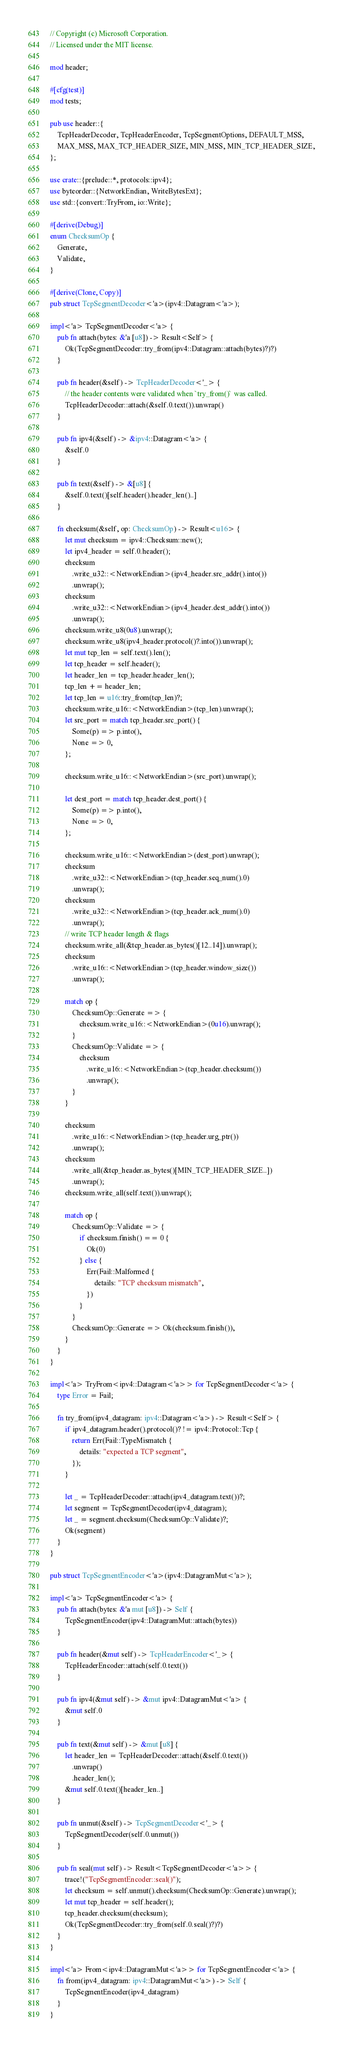<code> <loc_0><loc_0><loc_500><loc_500><_Rust_>// Copyright (c) Microsoft Corporation.
// Licensed under the MIT license.

mod header;

#[cfg(test)]
mod tests;

pub use header::{
    TcpHeaderDecoder, TcpHeaderEncoder, TcpSegmentOptions, DEFAULT_MSS,
    MAX_MSS, MAX_TCP_HEADER_SIZE, MIN_MSS, MIN_TCP_HEADER_SIZE,
};

use crate::{prelude::*, protocols::ipv4};
use byteorder::{NetworkEndian, WriteBytesExt};
use std::{convert::TryFrom, io::Write};

#[derive(Debug)]
enum ChecksumOp {
    Generate,
    Validate,
}

#[derive(Clone, Copy)]
pub struct TcpSegmentDecoder<'a>(ipv4::Datagram<'a>);

impl<'a> TcpSegmentDecoder<'a> {
    pub fn attach(bytes: &'a [u8]) -> Result<Self> {
        Ok(TcpSegmentDecoder::try_from(ipv4::Datagram::attach(bytes)?)?)
    }

    pub fn header(&self) -> TcpHeaderDecoder<'_> {
        // the header contents were validated when `try_from()` was called.
        TcpHeaderDecoder::attach(&self.0.text()).unwrap()
    }

    pub fn ipv4(&self) -> &ipv4::Datagram<'a> {
        &self.0
    }

    pub fn text(&self) -> &[u8] {
        &self.0.text()[self.header().header_len()..]
    }

    fn checksum(&self, op: ChecksumOp) -> Result<u16> {
        let mut checksum = ipv4::Checksum::new();
        let ipv4_header = self.0.header();
        checksum
            .write_u32::<NetworkEndian>(ipv4_header.src_addr().into())
            .unwrap();
        checksum
            .write_u32::<NetworkEndian>(ipv4_header.dest_addr().into())
            .unwrap();
        checksum.write_u8(0u8).unwrap();
        checksum.write_u8(ipv4_header.protocol()?.into()).unwrap();
        let mut tcp_len = self.text().len();
        let tcp_header = self.header();
        let header_len = tcp_header.header_len();
        tcp_len += header_len;
        let tcp_len = u16::try_from(tcp_len)?;
        checksum.write_u16::<NetworkEndian>(tcp_len).unwrap();
        let src_port = match tcp_header.src_port() {
            Some(p) => p.into(),
            None => 0,
        };

        checksum.write_u16::<NetworkEndian>(src_port).unwrap();

        let dest_port = match tcp_header.dest_port() {
            Some(p) => p.into(),
            None => 0,
        };

        checksum.write_u16::<NetworkEndian>(dest_port).unwrap();
        checksum
            .write_u32::<NetworkEndian>(tcp_header.seq_num().0)
            .unwrap();
        checksum
            .write_u32::<NetworkEndian>(tcp_header.ack_num().0)
            .unwrap();
        // write TCP header length & flags
        checksum.write_all(&tcp_header.as_bytes()[12..14]).unwrap();
        checksum
            .write_u16::<NetworkEndian>(tcp_header.window_size())
            .unwrap();

        match op {
            ChecksumOp::Generate => {
                checksum.write_u16::<NetworkEndian>(0u16).unwrap();
            }
            ChecksumOp::Validate => {
                checksum
                    .write_u16::<NetworkEndian>(tcp_header.checksum())
                    .unwrap();
            }
        }

        checksum
            .write_u16::<NetworkEndian>(tcp_header.urg_ptr())
            .unwrap();
        checksum
            .write_all(&tcp_header.as_bytes()[MIN_TCP_HEADER_SIZE..])
            .unwrap();
        checksum.write_all(self.text()).unwrap();

        match op {
            ChecksumOp::Validate => {
                if checksum.finish() == 0 {
                    Ok(0)
                } else {
                    Err(Fail::Malformed {
                        details: "TCP checksum mismatch",
                    })
                }
            }
            ChecksumOp::Generate => Ok(checksum.finish()),
        }
    }
}

impl<'a> TryFrom<ipv4::Datagram<'a>> for TcpSegmentDecoder<'a> {
    type Error = Fail;

    fn try_from(ipv4_datagram: ipv4::Datagram<'a>) -> Result<Self> {
        if ipv4_datagram.header().protocol()? != ipv4::Protocol::Tcp {
            return Err(Fail::TypeMismatch {
                details: "expected a TCP segment",
            });
        }

        let _ = TcpHeaderDecoder::attach(ipv4_datagram.text())?;
        let segment = TcpSegmentDecoder(ipv4_datagram);
        let _ = segment.checksum(ChecksumOp::Validate)?;
        Ok(segment)
    }
}

pub struct TcpSegmentEncoder<'a>(ipv4::DatagramMut<'a>);

impl<'a> TcpSegmentEncoder<'a> {
    pub fn attach(bytes: &'a mut [u8]) -> Self {
        TcpSegmentEncoder(ipv4::DatagramMut::attach(bytes))
    }

    pub fn header(&mut self) -> TcpHeaderEncoder<'_> {
        TcpHeaderEncoder::attach(self.0.text())
    }

    pub fn ipv4(&mut self) -> &mut ipv4::DatagramMut<'a> {
        &mut self.0
    }

    pub fn text(&mut self) -> &mut [u8] {
        let header_len = TcpHeaderDecoder::attach(&self.0.text())
            .unwrap()
            .header_len();
        &mut self.0.text()[header_len..]
    }

    pub fn unmut(&self) -> TcpSegmentDecoder<'_> {
        TcpSegmentDecoder(self.0.unmut())
    }

    pub fn seal(mut self) -> Result<TcpSegmentDecoder<'a>> {
        trace!("TcpSegmentEncoder::seal()");
        let checksum = self.unmut().checksum(ChecksumOp::Generate).unwrap();
        let mut tcp_header = self.header();
        tcp_header.checksum(checksum);
        Ok(TcpSegmentDecoder::try_from(self.0.seal()?)?)
    }
}

impl<'a> From<ipv4::DatagramMut<'a>> for TcpSegmentEncoder<'a> {
    fn from(ipv4_datagram: ipv4::DatagramMut<'a>) -> Self {
        TcpSegmentEncoder(ipv4_datagram)
    }
}
</code> 